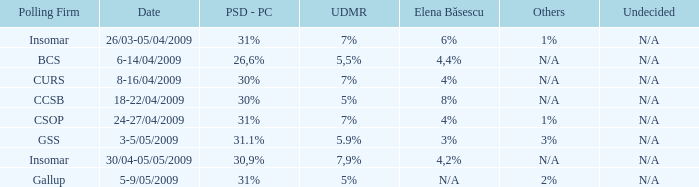What was the UDMR for 18-22/04/2009? 5%. 